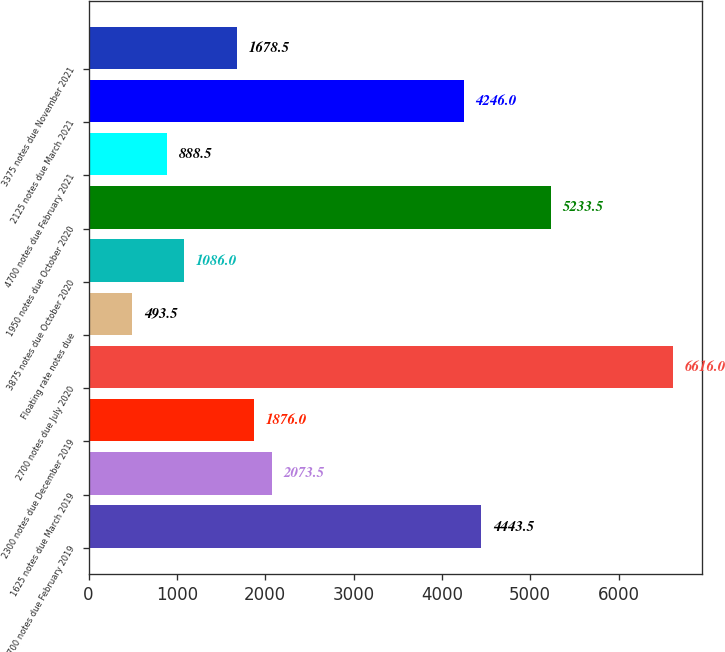Convert chart. <chart><loc_0><loc_0><loc_500><loc_500><bar_chart><fcel>1700 notes due February 2019<fcel>1625 notes due March 2019<fcel>2300 notes due December 2019<fcel>2700 notes due July 2020<fcel>Floating rate notes due<fcel>3875 notes due October 2020<fcel>1950 notes due October 2020<fcel>4700 notes due February 2021<fcel>2125 notes due March 2021<fcel>3375 notes due November 2021<nl><fcel>4443.5<fcel>2073.5<fcel>1876<fcel>6616<fcel>493.5<fcel>1086<fcel>5233.5<fcel>888.5<fcel>4246<fcel>1678.5<nl></chart> 